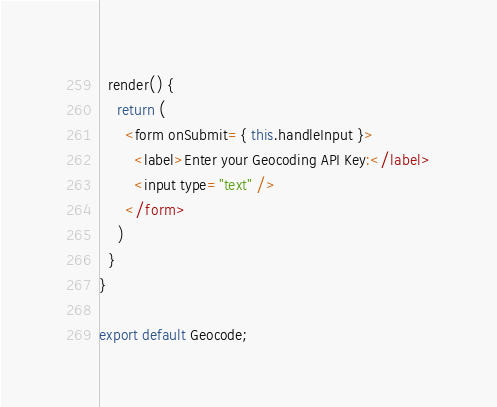Convert code to text. <code><loc_0><loc_0><loc_500><loc_500><_JavaScript_>  render() {
    return (
      <form onSubmit={ this.handleInput }>
        <label>Enter your Geocoding API Key:</label>
        <input type="text" />
      </form>
    )
  }
}

export default Geocode;
</code> 